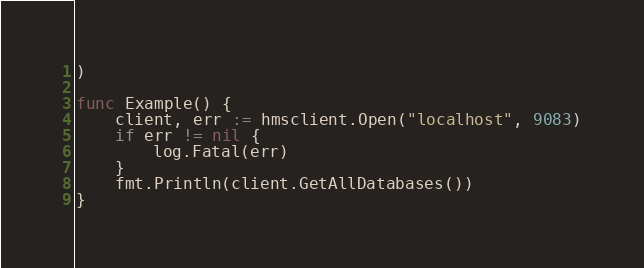Convert code to text. <code><loc_0><loc_0><loc_500><loc_500><_Go_>)

func Example() {
	client, err := hmsclient.Open("localhost", 9083)
	if err != nil {
		log.Fatal(err)
	}
	fmt.Println(client.GetAllDatabases())
}
</code> 